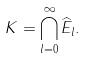<formula> <loc_0><loc_0><loc_500><loc_500>K = \bigcap _ { l = 0 } ^ { \infty } \widehat { E } _ { l } .</formula> 